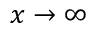<formula> <loc_0><loc_0><loc_500><loc_500>x \rightarrow \infty</formula> 